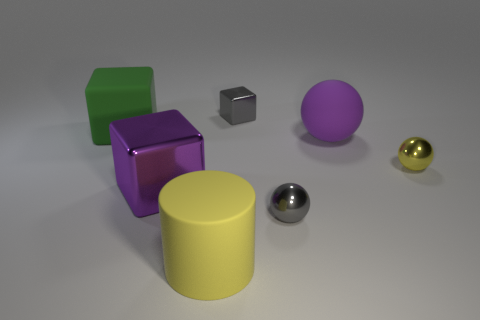Add 1 blue metal things. How many objects exist? 8 Subtract all spheres. How many objects are left? 4 Add 5 large purple matte spheres. How many large purple matte spheres exist? 6 Subtract 0 red balls. How many objects are left? 7 Subtract all big matte blocks. Subtract all large purple matte things. How many objects are left? 5 Add 2 small gray metallic things. How many small gray metallic things are left? 4 